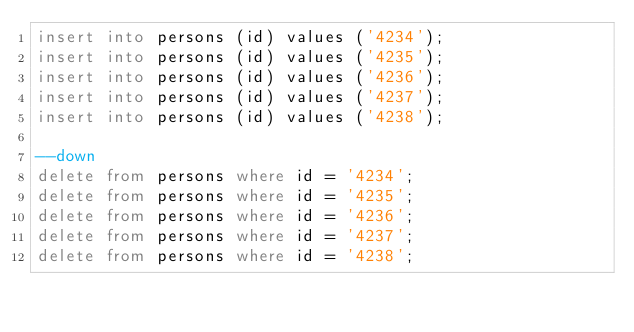<code> <loc_0><loc_0><loc_500><loc_500><_SQL_>insert into persons (id) values ('4234');
insert into persons (id) values ('4235');
insert into persons (id) values ('4236');
insert into persons (id) values ('4237');
insert into persons (id) values ('4238');

--down
delete from persons where id = '4234';
delete from persons where id = '4235';
delete from persons where id = '4236';
delete from persons where id = '4237';
delete from persons where id = '4238';</code> 